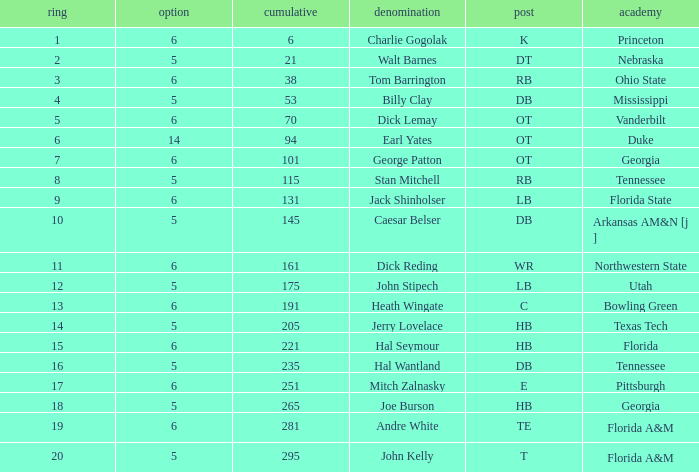What is Name, when Overall is less than 175, and when College is "Georgia"? George Patton. 